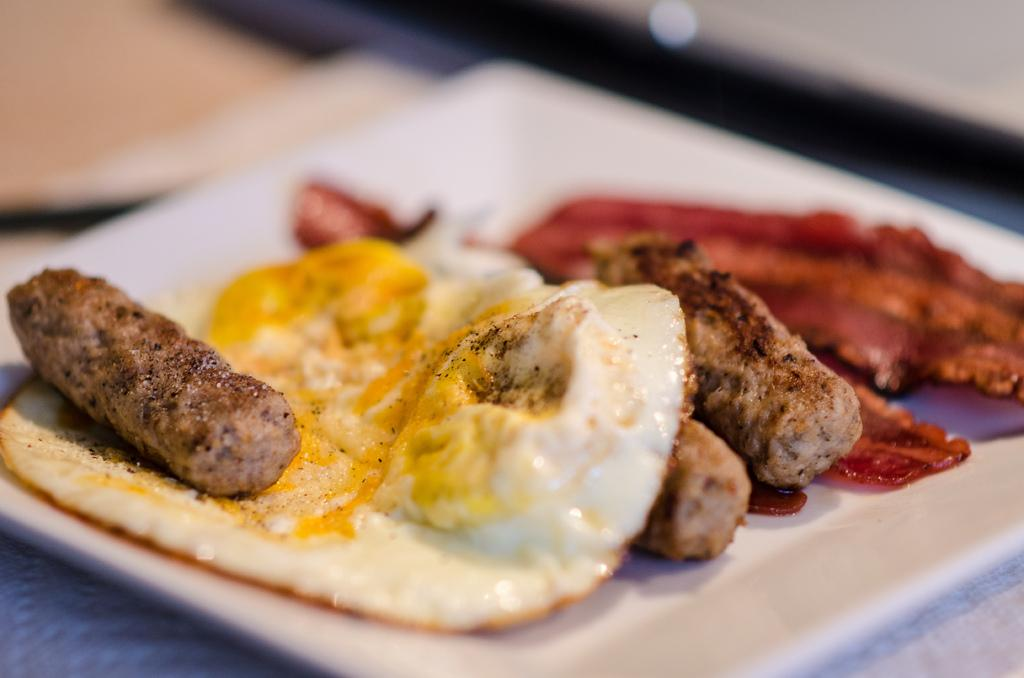What type of food can be seen in the image? The food in the image consists of an egg omelette and flesh. Can you describe the preparation of the egg omelette? The facts provided do not give information about the preparation of the egg omelette. How is the food arranged in the image? The food is placed on a plate in the image. Where is the plate located? The plate is kept on a table in the image. How many chickens are visible in the image? There are no chickens visible in the image. What type of soap is used to clean the plate in the image? There is no soap present in the image, as it is focused on the food and its arrangement. 